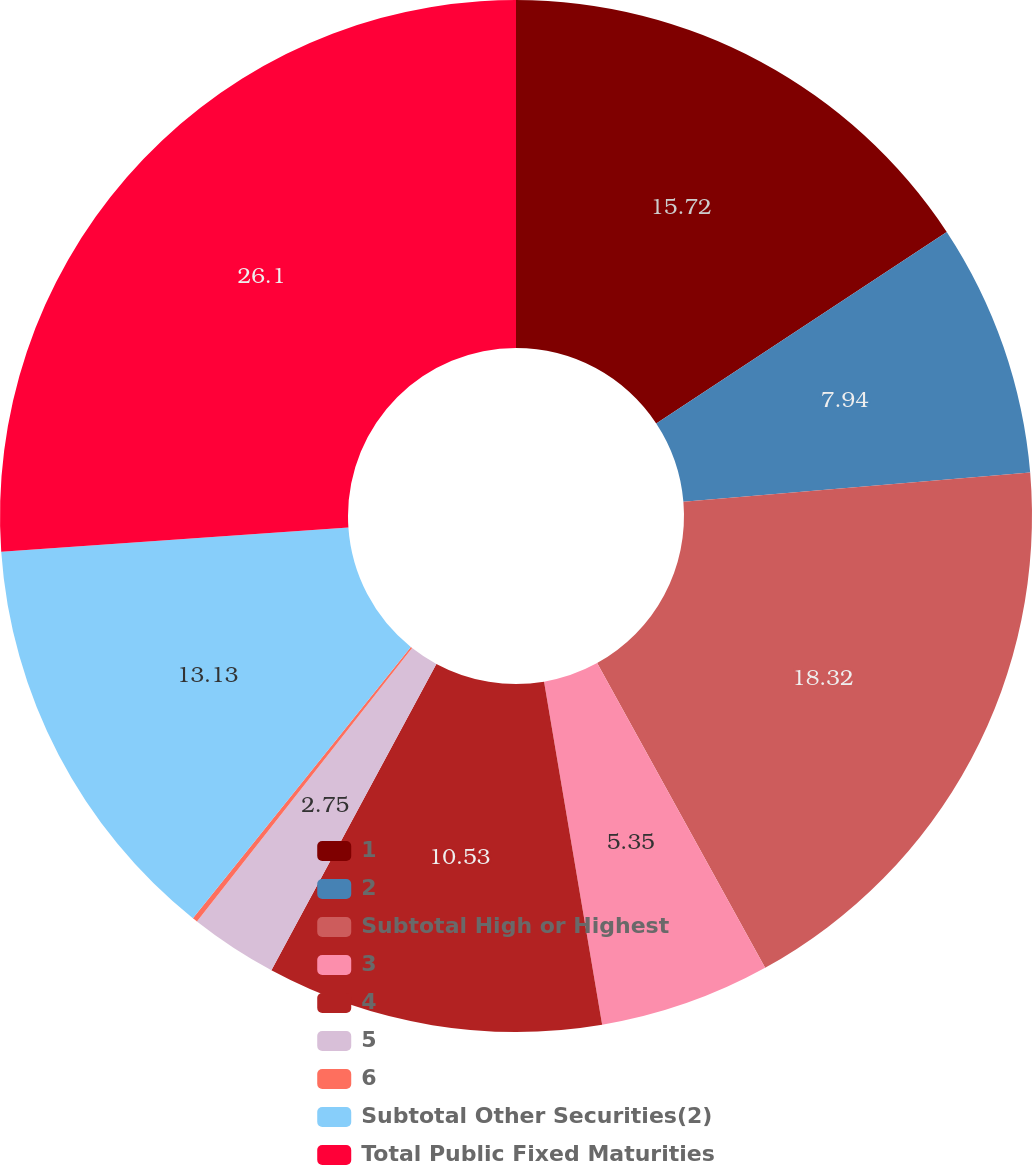Convert chart. <chart><loc_0><loc_0><loc_500><loc_500><pie_chart><fcel>1<fcel>2<fcel>Subtotal High or Highest<fcel>3<fcel>4<fcel>5<fcel>6<fcel>Subtotal Other Securities(2)<fcel>Total Public Fixed Maturities<nl><fcel>15.72%<fcel>7.94%<fcel>18.32%<fcel>5.35%<fcel>10.53%<fcel>2.75%<fcel>0.16%<fcel>13.13%<fcel>26.1%<nl></chart> 